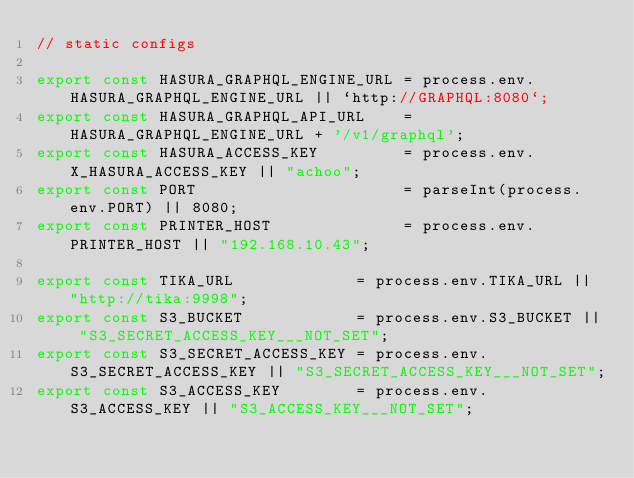<code> <loc_0><loc_0><loc_500><loc_500><_TypeScript_>// static configs

export const HASURA_GRAPHQL_ENGINE_URL = process.env.HASURA_GRAPHQL_ENGINE_URL || `http://GRAPHQL:8080`;
export const HASURA_GRAPHQL_API_URL    = HASURA_GRAPHQL_ENGINE_URL + '/v1/graphql';
export const HASURA_ACCESS_KEY         = process.env.X_HASURA_ACCESS_KEY || "achoo";
export const PORT                      = parseInt(process.env.PORT) || 8080;
export const PRINTER_HOST              = process.env.PRINTER_HOST || "192.168.10.43";

export const TIKA_URL             = process.env.TIKA_URL || "http://tika:9998";
export const S3_BUCKET            = process.env.S3_BUCKET || "S3_SECRET_ACCESS_KEY___NOT_SET";
export const S3_SECRET_ACCESS_KEY = process.env.S3_SECRET_ACCESS_KEY || "S3_SECRET_ACCESS_KEY___NOT_SET";
export const S3_ACCESS_KEY        = process.env.S3_ACCESS_KEY || "S3_ACCESS_KEY___NOT_SET";</code> 